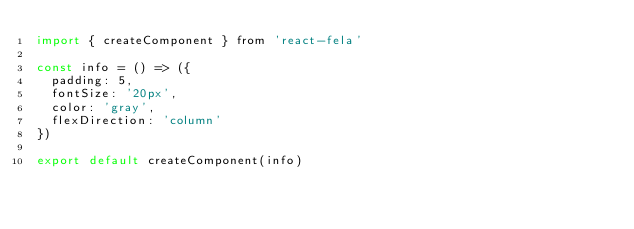Convert code to text. <code><loc_0><loc_0><loc_500><loc_500><_JavaScript_>import { createComponent } from 'react-fela'

const info = () => ({
  padding: 5,
  fontSize: '20px',
  color: 'gray',
  flexDirection: 'column'
})

export default createComponent(info)
</code> 